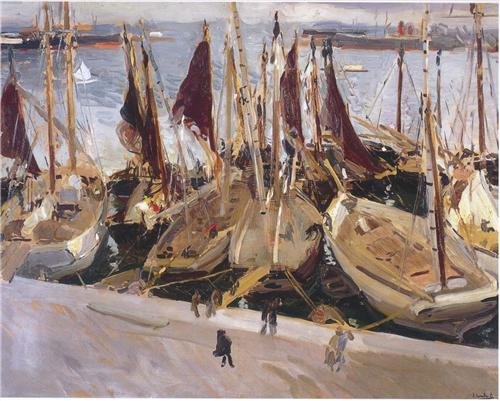How might this harbor appear during a festive celebration? During a festive celebration, the harbor would be a riot of colors and lights. Decorated boats line the docks, adorned with strings of bright, multicolored flags and lanterns. The water reflects the shimmering lights, creating a dazzling display. Stalls are set up along the waterfront, selling local delicacies and handmade crafts. Music fills the air, and people from all walks of life, dressed in vibrant attire, move through the docks in joyous celebration. Fireworks perhaps light up the evening sky, their vivid colors mirrored in the water below, adding to the festive atmosphere. The entire harbor would be transformed into a lively, pulsating heart of the city, celebrating community and tradition. How long have you been part of this bustling harbor? I have been part of this bustling harbor for as long as I can remember. It's as if the rhythm of the tides flows through my veins, the call of the sea echoing in my heart. The harbor has been my home, my workplace, and my playground. I've seen it through many phases, from the quiet early mornings to the rushed and lively afternoons, and the serene, reflective evenings. I've watched it grow, change, and thrive, and in return, it's shaped who I am. The harbor is more than just a place to me; it's a living, breathing entity that holds endless stories, adventures, and memories. 